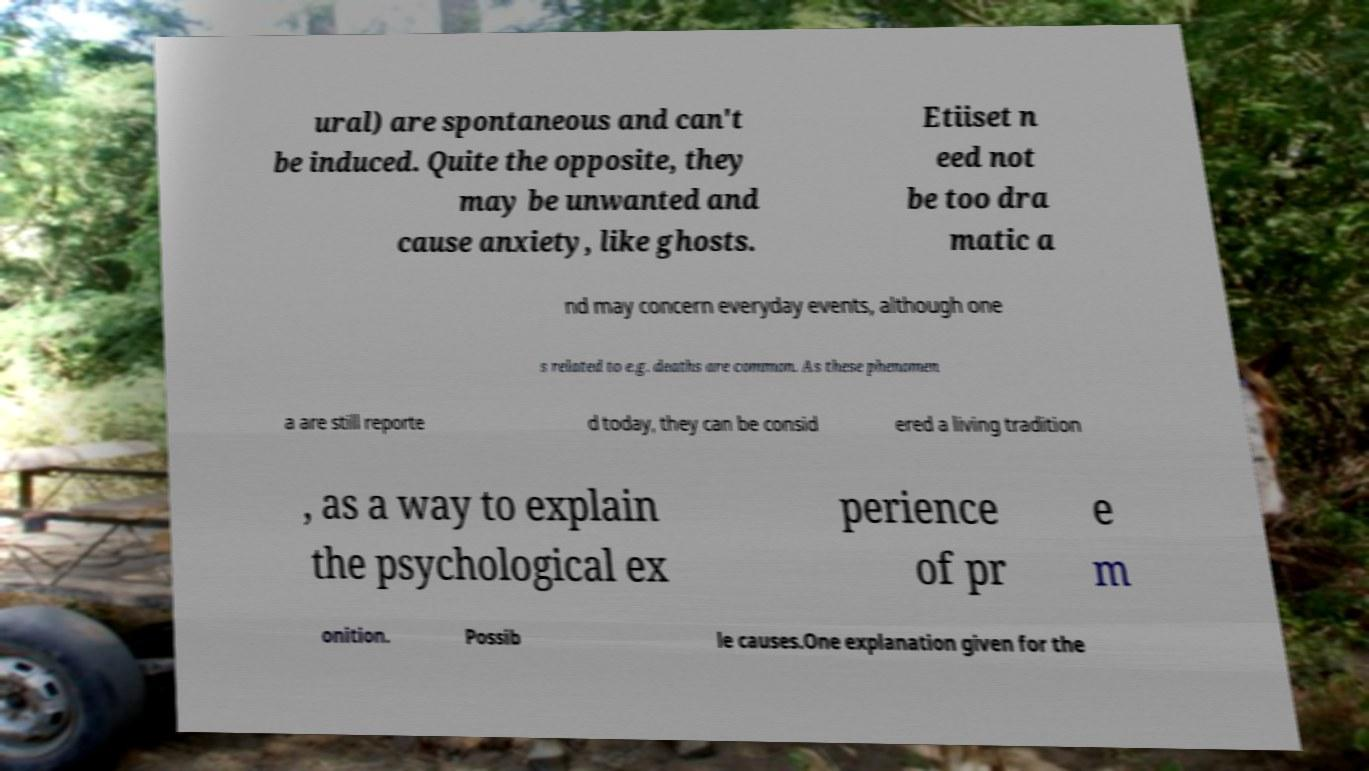For documentation purposes, I need the text within this image transcribed. Could you provide that? ural) are spontaneous and can't be induced. Quite the opposite, they may be unwanted and cause anxiety, like ghosts. Etiiset n eed not be too dra matic a nd may concern everyday events, although one s related to e.g. deaths are common. As these phenomen a are still reporte d today, they can be consid ered a living tradition , as a way to explain the psychological ex perience of pr e m onition. Possib le causes.One explanation given for the 